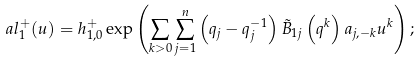<formula> <loc_0><loc_0><loc_500><loc_500>\ a l _ { 1 } ^ { + } ( u ) = h _ { 1 , 0 } ^ { + } \exp \left ( \sum _ { k > 0 } \sum _ { j = 1 } ^ { n } \left ( q _ { j } - q _ { j } ^ { - 1 } \right ) \tilde { B } _ { 1 j } \left ( q ^ { k } \right ) a _ { j , - k } u ^ { k } \right ) ;</formula> 